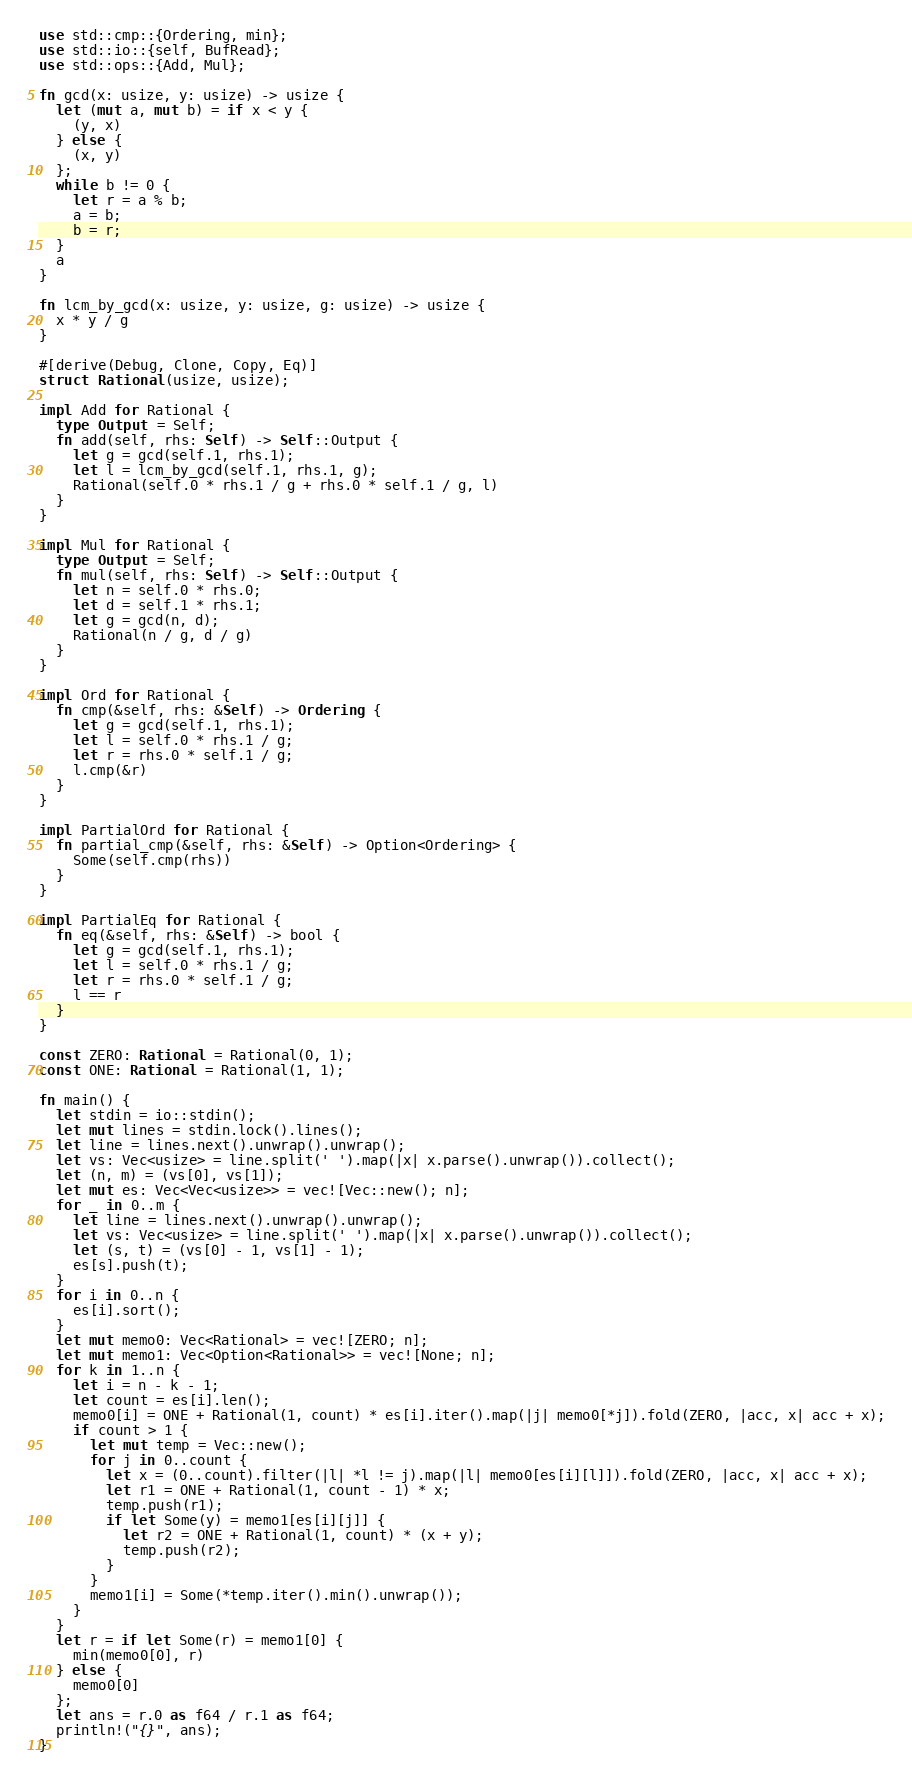<code> <loc_0><loc_0><loc_500><loc_500><_Rust_>use std::cmp::{Ordering, min};
use std::io::{self, BufRead};
use std::ops::{Add, Mul};

fn gcd(x: usize, y: usize) -> usize {
  let (mut a, mut b) = if x < y {
    (y, x)
  } else {
    (x, y)
  };
  while b != 0 {
    let r = a % b;
    a = b;
    b = r;
  }
  a
}

fn lcm_by_gcd(x: usize, y: usize, g: usize) -> usize {
  x * y / g
}

#[derive(Debug, Clone, Copy, Eq)]
struct Rational(usize, usize);

impl Add for Rational {
  type Output = Self;
  fn add(self, rhs: Self) -> Self::Output {
    let g = gcd(self.1, rhs.1);
    let l = lcm_by_gcd(self.1, rhs.1, g);
    Rational(self.0 * rhs.1 / g + rhs.0 * self.1 / g, l)
  }
}

impl Mul for Rational {
  type Output = Self;
  fn mul(self, rhs: Self) -> Self::Output {
    let n = self.0 * rhs.0;
    let d = self.1 * rhs.1;
    let g = gcd(n, d);
    Rational(n / g, d / g)
  }
}

impl Ord for Rational {
  fn cmp(&self, rhs: &Self) -> Ordering {
    let g = gcd(self.1, rhs.1);
    let l = self.0 * rhs.1 / g;
    let r = rhs.0 * self.1 / g;
    l.cmp(&r)
  }
}

impl PartialOrd for Rational {
  fn partial_cmp(&self, rhs: &Self) -> Option<Ordering> {
    Some(self.cmp(rhs))
  }
}

impl PartialEq for Rational {
  fn eq(&self, rhs: &Self) -> bool {
    let g = gcd(self.1, rhs.1);
    let l = self.0 * rhs.1 / g;
    let r = rhs.0 * self.1 / g;
    l == r
  }
}

const ZERO: Rational = Rational(0, 1);
const ONE: Rational = Rational(1, 1);

fn main() {
  let stdin = io::stdin();
  let mut lines = stdin.lock().lines();
  let line = lines.next().unwrap().unwrap();
  let vs: Vec<usize> = line.split(' ').map(|x| x.parse().unwrap()).collect();
  let (n, m) = (vs[0], vs[1]);
  let mut es: Vec<Vec<usize>> = vec![Vec::new(); n];
  for _ in 0..m {
    let line = lines.next().unwrap().unwrap();
    let vs: Vec<usize> = line.split(' ').map(|x| x.parse().unwrap()).collect();
    let (s, t) = (vs[0] - 1, vs[1] - 1);
    es[s].push(t);
  }
  for i in 0..n {
    es[i].sort();
  }
  let mut memo0: Vec<Rational> = vec![ZERO; n];
  let mut memo1: Vec<Option<Rational>> = vec![None; n];
  for k in 1..n {
    let i = n - k - 1;
    let count = es[i].len();
    memo0[i] = ONE + Rational(1, count) * es[i].iter().map(|j| memo0[*j]).fold(ZERO, |acc, x| acc + x);
    if count > 1 {
      let mut temp = Vec::new();
      for j in 0..count {
        let x = (0..count).filter(|l| *l != j).map(|l| memo0[es[i][l]]).fold(ZERO, |acc, x| acc + x);
        let r1 = ONE + Rational(1, count - 1) * x;
        temp.push(r1);
        if let Some(y) = memo1[es[i][j]] {
          let r2 = ONE + Rational(1, count) * (x + y);
          temp.push(r2);
        }
      }
      memo1[i] = Some(*temp.iter().min().unwrap());
    }
  }
  let r = if let Some(r) = memo1[0] {
    min(memo0[0], r)
  } else {
    memo0[0]
  };
  let ans = r.0 as f64 / r.1 as f64;
  println!("{}", ans);
}</code> 